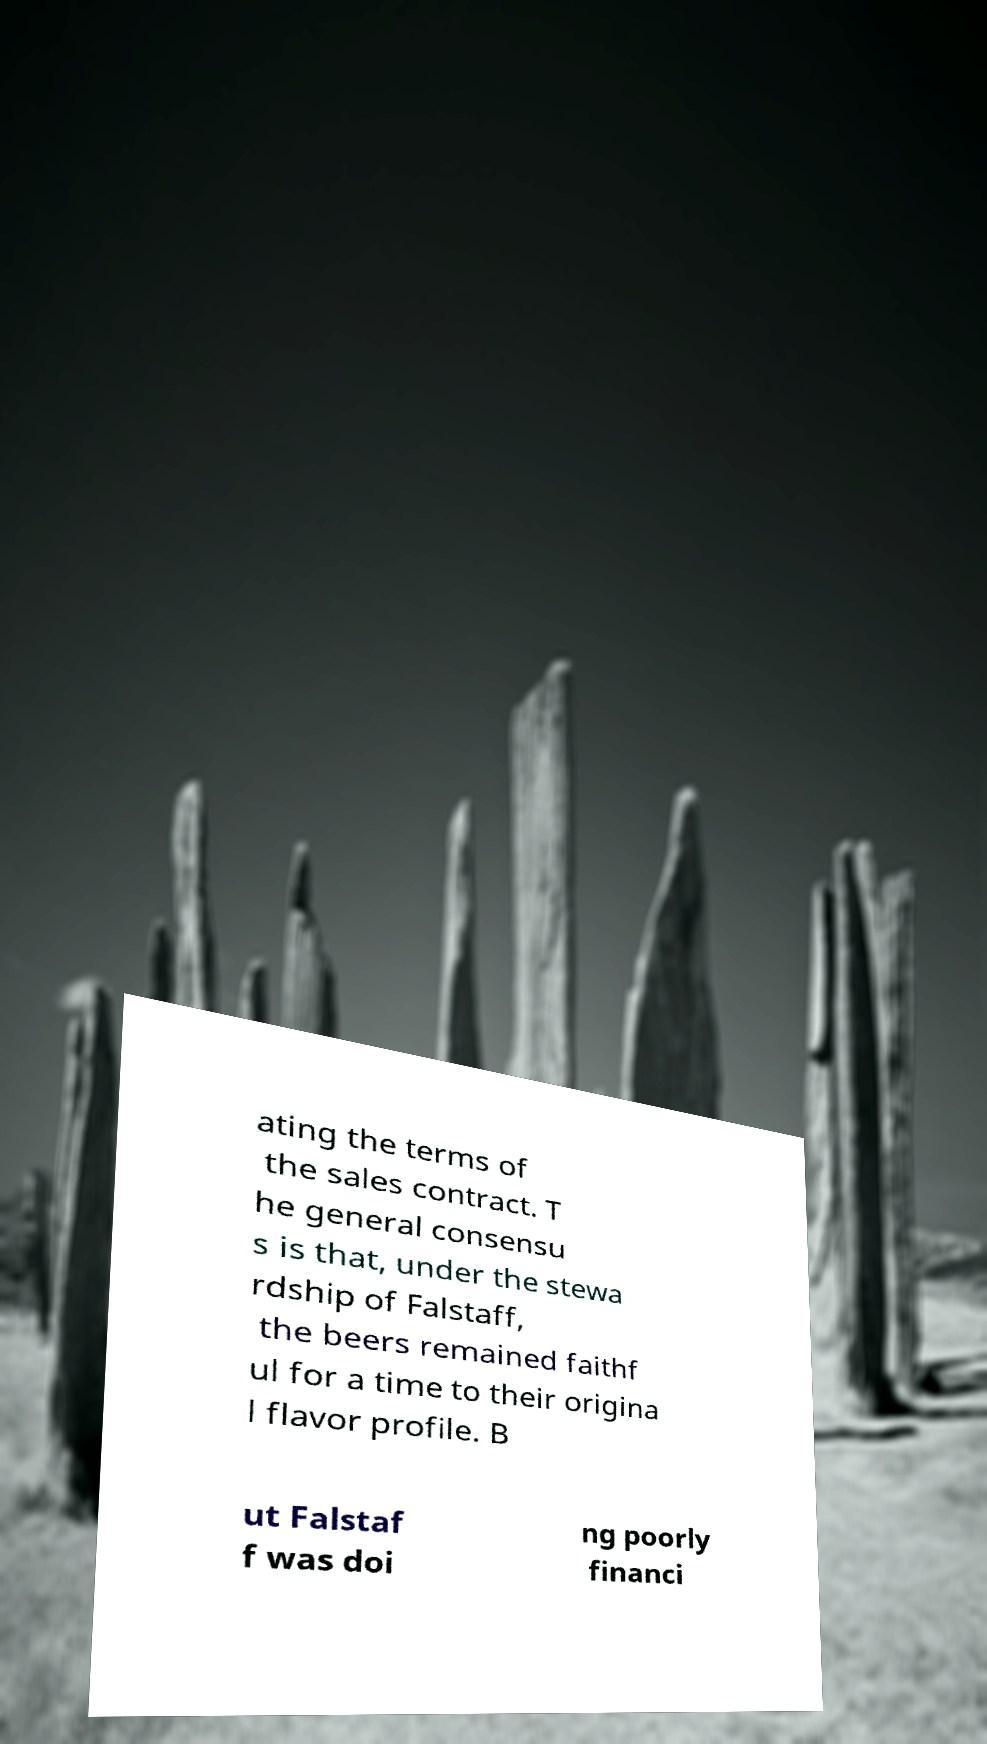What messages or text are displayed in this image? I need them in a readable, typed format. ating the terms of the sales contract. T he general consensu s is that, under the stewa rdship of Falstaff, the beers remained faithf ul for a time to their origina l flavor profile. B ut Falstaf f was doi ng poorly financi 